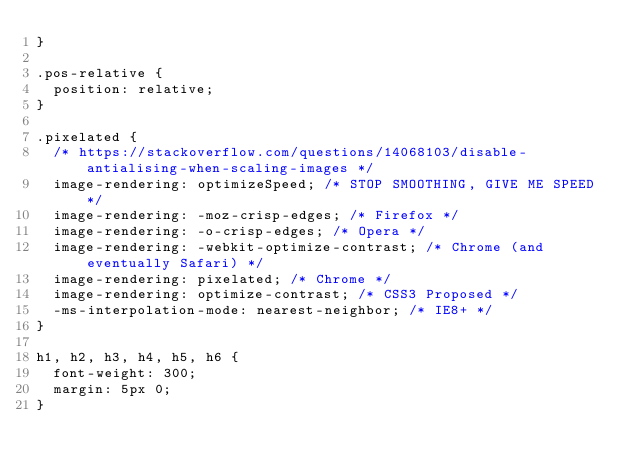Convert code to text. <code><loc_0><loc_0><loc_500><loc_500><_CSS_>}

.pos-relative {
  position: relative;
}

.pixelated {
  /* https://stackoverflow.com/questions/14068103/disable-antialising-when-scaling-images */
  image-rendering: optimizeSpeed; /* STOP SMOOTHING, GIVE ME SPEED */
  image-rendering: -moz-crisp-edges; /* Firefox */
  image-rendering: -o-crisp-edges; /* Opera */
  image-rendering: -webkit-optimize-contrast; /* Chrome (and eventually Safari) */
  image-rendering: pixelated; /* Chrome */
  image-rendering: optimize-contrast; /* CSS3 Proposed */
  -ms-interpolation-mode: nearest-neighbor; /* IE8+ */
}

h1, h2, h3, h4, h5, h6 {
  font-weight: 300;
  margin: 5px 0;
}
</code> 